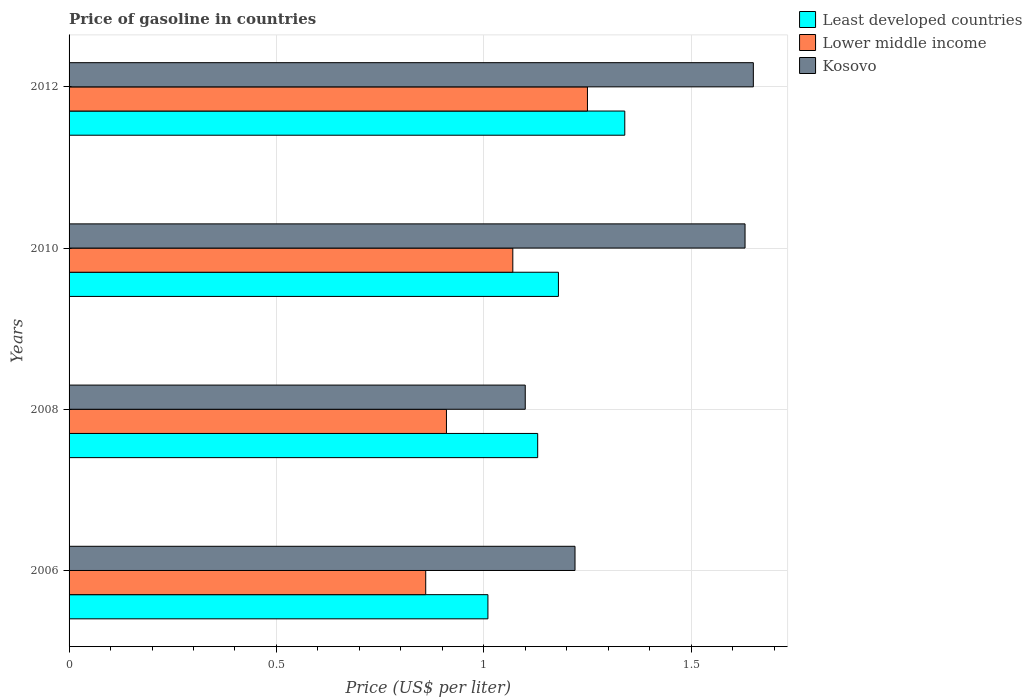How many different coloured bars are there?
Provide a short and direct response. 3. Are the number of bars per tick equal to the number of legend labels?
Offer a terse response. Yes. What is the label of the 1st group of bars from the top?
Ensure brevity in your answer.  2012. What is the price of gasoline in Least developed countries in 2010?
Provide a short and direct response. 1.18. Across all years, what is the maximum price of gasoline in Least developed countries?
Your answer should be very brief. 1.34. Across all years, what is the minimum price of gasoline in Kosovo?
Provide a succinct answer. 1.1. In which year was the price of gasoline in Kosovo maximum?
Your answer should be very brief. 2012. What is the total price of gasoline in Lower middle income in the graph?
Offer a terse response. 4.09. What is the difference between the price of gasoline in Lower middle income in 2010 and that in 2012?
Keep it short and to the point. -0.18. What is the difference between the price of gasoline in Kosovo in 2006 and the price of gasoline in Lower middle income in 2008?
Offer a terse response. 0.31. What is the average price of gasoline in Lower middle income per year?
Give a very brief answer. 1.02. In the year 2008, what is the difference between the price of gasoline in Lower middle income and price of gasoline in Least developed countries?
Provide a succinct answer. -0.22. In how many years, is the price of gasoline in Least developed countries greater than 0.1 US$?
Offer a terse response. 4. What is the ratio of the price of gasoline in Lower middle income in 2006 to that in 2010?
Make the answer very short. 0.8. Is the price of gasoline in Least developed countries in 2006 less than that in 2012?
Your answer should be very brief. Yes. What is the difference between the highest and the second highest price of gasoline in Kosovo?
Offer a terse response. 0.02. What is the difference between the highest and the lowest price of gasoline in Lower middle income?
Your response must be concise. 0.39. Is the sum of the price of gasoline in Least developed countries in 2010 and 2012 greater than the maximum price of gasoline in Kosovo across all years?
Provide a succinct answer. Yes. What does the 2nd bar from the top in 2008 represents?
Provide a succinct answer. Lower middle income. What does the 1st bar from the bottom in 2012 represents?
Provide a succinct answer. Least developed countries. Is it the case that in every year, the sum of the price of gasoline in Least developed countries and price of gasoline in Lower middle income is greater than the price of gasoline in Kosovo?
Offer a very short reply. Yes. Are all the bars in the graph horizontal?
Give a very brief answer. Yes. Are the values on the major ticks of X-axis written in scientific E-notation?
Make the answer very short. No. Does the graph contain any zero values?
Keep it short and to the point. No. Does the graph contain grids?
Provide a short and direct response. Yes. What is the title of the graph?
Offer a terse response. Price of gasoline in countries. What is the label or title of the X-axis?
Provide a succinct answer. Price (US$ per liter). What is the Price (US$ per liter) in Lower middle income in 2006?
Provide a succinct answer. 0.86. What is the Price (US$ per liter) of Kosovo in 2006?
Provide a succinct answer. 1.22. What is the Price (US$ per liter) of Least developed countries in 2008?
Your answer should be very brief. 1.13. What is the Price (US$ per liter) of Lower middle income in 2008?
Your response must be concise. 0.91. What is the Price (US$ per liter) of Least developed countries in 2010?
Your response must be concise. 1.18. What is the Price (US$ per liter) of Lower middle income in 2010?
Keep it short and to the point. 1.07. What is the Price (US$ per liter) in Kosovo in 2010?
Ensure brevity in your answer.  1.63. What is the Price (US$ per liter) in Least developed countries in 2012?
Provide a succinct answer. 1.34. What is the Price (US$ per liter) in Kosovo in 2012?
Make the answer very short. 1.65. Across all years, what is the maximum Price (US$ per liter) in Least developed countries?
Offer a terse response. 1.34. Across all years, what is the maximum Price (US$ per liter) of Kosovo?
Provide a succinct answer. 1.65. Across all years, what is the minimum Price (US$ per liter) in Lower middle income?
Your answer should be very brief. 0.86. What is the total Price (US$ per liter) in Least developed countries in the graph?
Ensure brevity in your answer.  4.66. What is the total Price (US$ per liter) of Lower middle income in the graph?
Offer a very short reply. 4.09. What is the total Price (US$ per liter) in Kosovo in the graph?
Your answer should be very brief. 5.6. What is the difference between the Price (US$ per liter) in Least developed countries in 2006 and that in 2008?
Your answer should be very brief. -0.12. What is the difference between the Price (US$ per liter) in Kosovo in 2006 and that in 2008?
Give a very brief answer. 0.12. What is the difference between the Price (US$ per liter) in Least developed countries in 2006 and that in 2010?
Give a very brief answer. -0.17. What is the difference between the Price (US$ per liter) in Lower middle income in 2006 and that in 2010?
Your response must be concise. -0.21. What is the difference between the Price (US$ per liter) of Kosovo in 2006 and that in 2010?
Your response must be concise. -0.41. What is the difference between the Price (US$ per liter) in Least developed countries in 2006 and that in 2012?
Ensure brevity in your answer.  -0.33. What is the difference between the Price (US$ per liter) of Lower middle income in 2006 and that in 2012?
Ensure brevity in your answer.  -0.39. What is the difference between the Price (US$ per liter) in Kosovo in 2006 and that in 2012?
Provide a succinct answer. -0.43. What is the difference between the Price (US$ per liter) in Least developed countries in 2008 and that in 2010?
Ensure brevity in your answer.  -0.05. What is the difference between the Price (US$ per liter) of Lower middle income in 2008 and that in 2010?
Your answer should be very brief. -0.16. What is the difference between the Price (US$ per liter) in Kosovo in 2008 and that in 2010?
Your answer should be compact. -0.53. What is the difference between the Price (US$ per liter) of Least developed countries in 2008 and that in 2012?
Offer a very short reply. -0.21. What is the difference between the Price (US$ per liter) in Lower middle income in 2008 and that in 2012?
Keep it short and to the point. -0.34. What is the difference between the Price (US$ per liter) of Kosovo in 2008 and that in 2012?
Your answer should be very brief. -0.55. What is the difference between the Price (US$ per liter) of Least developed countries in 2010 and that in 2012?
Offer a terse response. -0.16. What is the difference between the Price (US$ per liter) in Lower middle income in 2010 and that in 2012?
Your answer should be compact. -0.18. What is the difference between the Price (US$ per liter) of Kosovo in 2010 and that in 2012?
Your answer should be compact. -0.02. What is the difference between the Price (US$ per liter) of Least developed countries in 2006 and the Price (US$ per liter) of Kosovo in 2008?
Keep it short and to the point. -0.09. What is the difference between the Price (US$ per liter) of Lower middle income in 2006 and the Price (US$ per liter) of Kosovo in 2008?
Your response must be concise. -0.24. What is the difference between the Price (US$ per liter) of Least developed countries in 2006 and the Price (US$ per liter) of Lower middle income in 2010?
Provide a succinct answer. -0.06. What is the difference between the Price (US$ per liter) of Least developed countries in 2006 and the Price (US$ per liter) of Kosovo in 2010?
Provide a succinct answer. -0.62. What is the difference between the Price (US$ per liter) of Lower middle income in 2006 and the Price (US$ per liter) of Kosovo in 2010?
Your answer should be very brief. -0.77. What is the difference between the Price (US$ per liter) of Least developed countries in 2006 and the Price (US$ per liter) of Lower middle income in 2012?
Your answer should be compact. -0.24. What is the difference between the Price (US$ per liter) of Least developed countries in 2006 and the Price (US$ per liter) of Kosovo in 2012?
Keep it short and to the point. -0.64. What is the difference between the Price (US$ per liter) in Lower middle income in 2006 and the Price (US$ per liter) in Kosovo in 2012?
Give a very brief answer. -0.79. What is the difference between the Price (US$ per liter) of Least developed countries in 2008 and the Price (US$ per liter) of Kosovo in 2010?
Your answer should be compact. -0.5. What is the difference between the Price (US$ per liter) of Lower middle income in 2008 and the Price (US$ per liter) of Kosovo in 2010?
Give a very brief answer. -0.72. What is the difference between the Price (US$ per liter) of Least developed countries in 2008 and the Price (US$ per liter) of Lower middle income in 2012?
Offer a very short reply. -0.12. What is the difference between the Price (US$ per liter) in Least developed countries in 2008 and the Price (US$ per liter) in Kosovo in 2012?
Your answer should be very brief. -0.52. What is the difference between the Price (US$ per liter) in Lower middle income in 2008 and the Price (US$ per liter) in Kosovo in 2012?
Ensure brevity in your answer.  -0.74. What is the difference between the Price (US$ per liter) in Least developed countries in 2010 and the Price (US$ per liter) in Lower middle income in 2012?
Provide a succinct answer. -0.07. What is the difference between the Price (US$ per liter) of Least developed countries in 2010 and the Price (US$ per liter) of Kosovo in 2012?
Offer a very short reply. -0.47. What is the difference between the Price (US$ per liter) in Lower middle income in 2010 and the Price (US$ per liter) in Kosovo in 2012?
Provide a short and direct response. -0.58. What is the average Price (US$ per liter) in Least developed countries per year?
Keep it short and to the point. 1.17. What is the average Price (US$ per liter) in Lower middle income per year?
Provide a succinct answer. 1.02. What is the average Price (US$ per liter) in Kosovo per year?
Provide a succinct answer. 1.4. In the year 2006, what is the difference between the Price (US$ per liter) of Least developed countries and Price (US$ per liter) of Kosovo?
Provide a short and direct response. -0.21. In the year 2006, what is the difference between the Price (US$ per liter) in Lower middle income and Price (US$ per liter) in Kosovo?
Offer a very short reply. -0.36. In the year 2008, what is the difference between the Price (US$ per liter) in Least developed countries and Price (US$ per liter) in Lower middle income?
Your response must be concise. 0.22. In the year 2008, what is the difference between the Price (US$ per liter) in Least developed countries and Price (US$ per liter) in Kosovo?
Keep it short and to the point. 0.03. In the year 2008, what is the difference between the Price (US$ per liter) in Lower middle income and Price (US$ per liter) in Kosovo?
Provide a short and direct response. -0.19. In the year 2010, what is the difference between the Price (US$ per liter) in Least developed countries and Price (US$ per liter) in Lower middle income?
Provide a succinct answer. 0.11. In the year 2010, what is the difference between the Price (US$ per liter) of Least developed countries and Price (US$ per liter) of Kosovo?
Make the answer very short. -0.45. In the year 2010, what is the difference between the Price (US$ per liter) of Lower middle income and Price (US$ per liter) of Kosovo?
Your answer should be compact. -0.56. In the year 2012, what is the difference between the Price (US$ per liter) in Least developed countries and Price (US$ per liter) in Lower middle income?
Your answer should be compact. 0.09. In the year 2012, what is the difference between the Price (US$ per liter) of Least developed countries and Price (US$ per liter) of Kosovo?
Offer a very short reply. -0.31. What is the ratio of the Price (US$ per liter) of Least developed countries in 2006 to that in 2008?
Your answer should be compact. 0.89. What is the ratio of the Price (US$ per liter) of Lower middle income in 2006 to that in 2008?
Keep it short and to the point. 0.95. What is the ratio of the Price (US$ per liter) in Kosovo in 2006 to that in 2008?
Make the answer very short. 1.11. What is the ratio of the Price (US$ per liter) in Least developed countries in 2006 to that in 2010?
Ensure brevity in your answer.  0.86. What is the ratio of the Price (US$ per liter) in Lower middle income in 2006 to that in 2010?
Give a very brief answer. 0.8. What is the ratio of the Price (US$ per liter) in Kosovo in 2006 to that in 2010?
Your answer should be compact. 0.75. What is the ratio of the Price (US$ per liter) of Least developed countries in 2006 to that in 2012?
Your answer should be compact. 0.75. What is the ratio of the Price (US$ per liter) in Lower middle income in 2006 to that in 2012?
Ensure brevity in your answer.  0.69. What is the ratio of the Price (US$ per liter) in Kosovo in 2006 to that in 2012?
Your answer should be very brief. 0.74. What is the ratio of the Price (US$ per liter) of Least developed countries in 2008 to that in 2010?
Offer a terse response. 0.96. What is the ratio of the Price (US$ per liter) in Lower middle income in 2008 to that in 2010?
Your response must be concise. 0.85. What is the ratio of the Price (US$ per liter) in Kosovo in 2008 to that in 2010?
Ensure brevity in your answer.  0.67. What is the ratio of the Price (US$ per liter) in Least developed countries in 2008 to that in 2012?
Give a very brief answer. 0.84. What is the ratio of the Price (US$ per liter) in Lower middle income in 2008 to that in 2012?
Offer a very short reply. 0.73. What is the ratio of the Price (US$ per liter) in Kosovo in 2008 to that in 2012?
Provide a succinct answer. 0.67. What is the ratio of the Price (US$ per liter) in Least developed countries in 2010 to that in 2012?
Keep it short and to the point. 0.88. What is the ratio of the Price (US$ per liter) in Lower middle income in 2010 to that in 2012?
Keep it short and to the point. 0.86. What is the ratio of the Price (US$ per liter) in Kosovo in 2010 to that in 2012?
Give a very brief answer. 0.99. What is the difference between the highest and the second highest Price (US$ per liter) of Least developed countries?
Make the answer very short. 0.16. What is the difference between the highest and the second highest Price (US$ per liter) of Lower middle income?
Your answer should be compact. 0.18. What is the difference between the highest and the lowest Price (US$ per liter) of Least developed countries?
Provide a short and direct response. 0.33. What is the difference between the highest and the lowest Price (US$ per liter) of Lower middle income?
Ensure brevity in your answer.  0.39. What is the difference between the highest and the lowest Price (US$ per liter) of Kosovo?
Give a very brief answer. 0.55. 